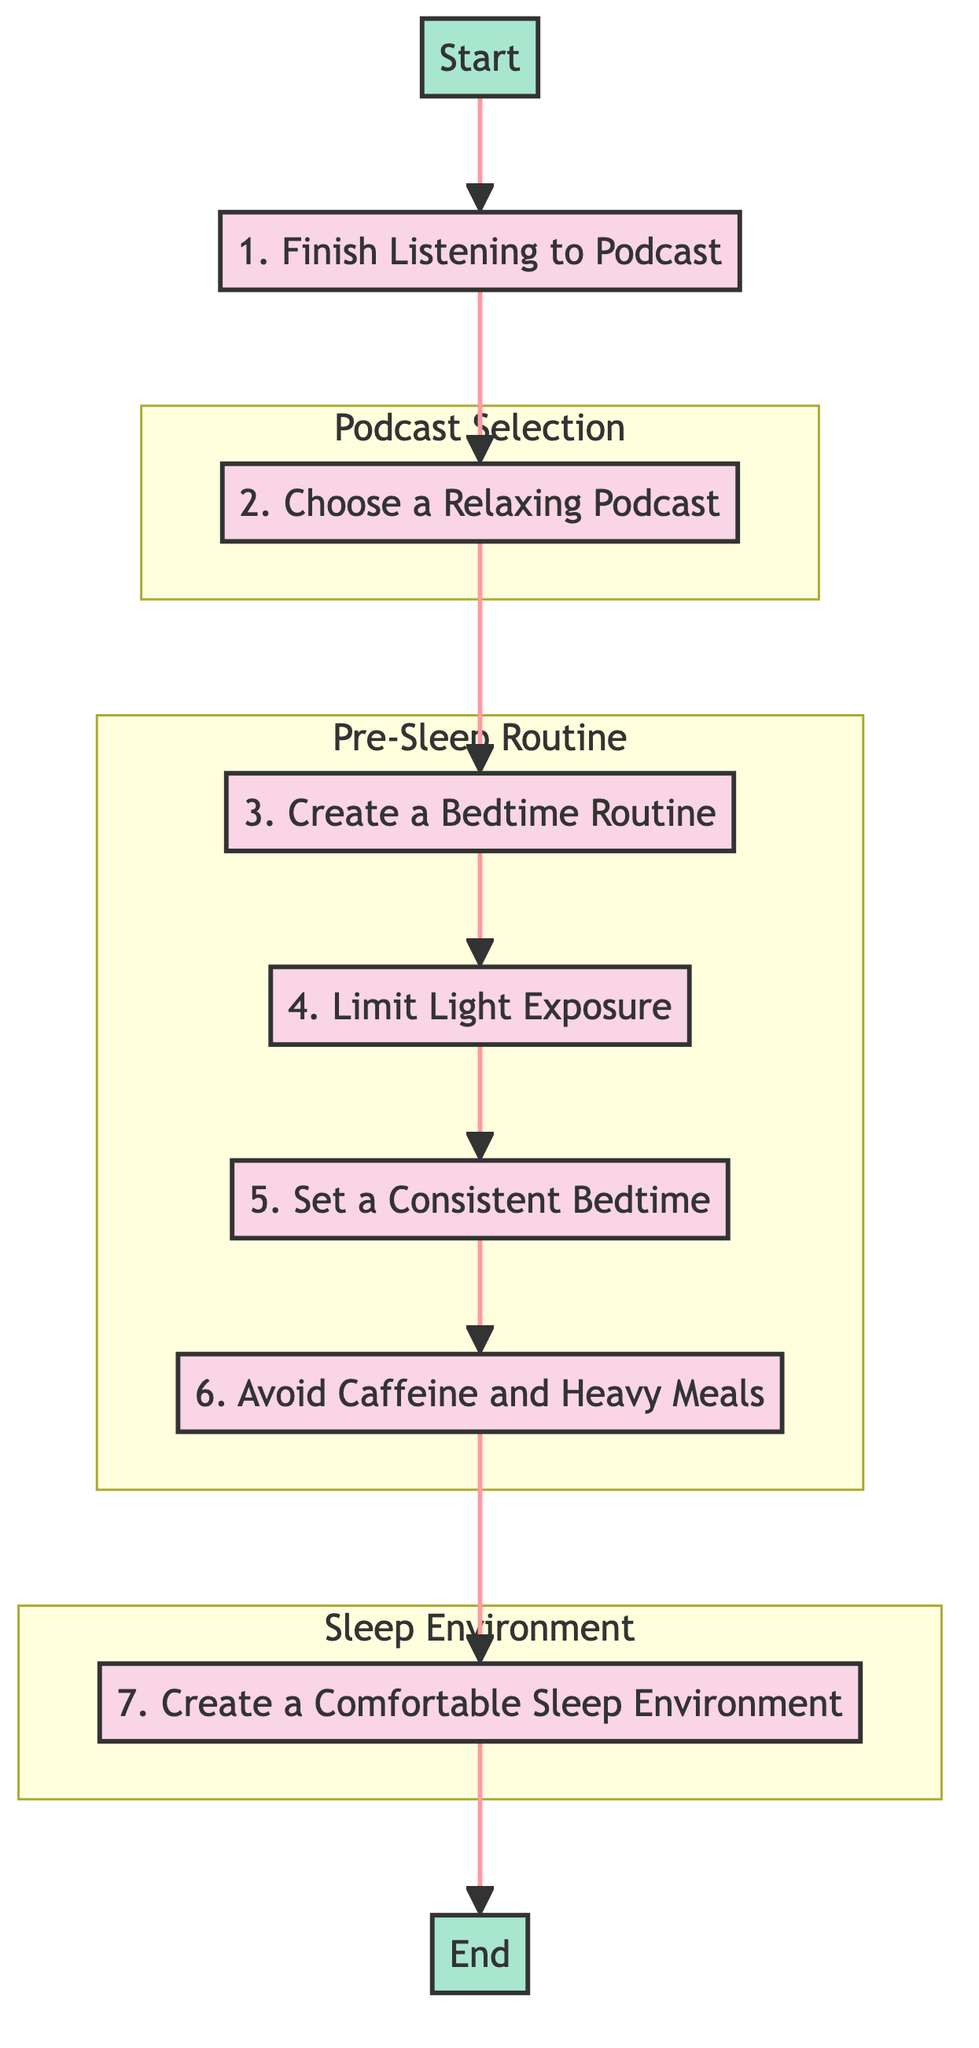What is the first step in the diagram? The first step is "Finish Listening to Podcast," which is represented only by node B in the diagram.
Answer: Finish Listening to Podcast How many steps are shown in the flow chart? Each step is represented by one node, and there are a total of 7 steps from B to H.
Answer: 7 Which step involves dimming lights? In step E, "Limit Light Exposure," it suggests dimming the lights as part of the bedtime routine.
Answer: Limit Light Exposure What is the last step to optimize sleep? The last step is to "Create a Comfortable Sleep Environment," represented by node H in the diagram.
Answer: Create a Comfortable Sleep Environment Which steps are grouped under the Pre-Sleep Routine? Steps D (Create a Bedtime Routine), E (Limit Light Exposure), F (Set a Consistent Bedtime), and G (Avoid Caffeine and Heavy Meals) are all part of that grouping.
Answer: Create a Bedtime Routine, Limit Light Exposure, Set a Consistent Bedtime, Avoid Caffeine and Heavy Meals How does "Choose a Relaxing Podcast" connect to "Finish Listening to Podcast"? "Choose a Relaxing Podcast" is directly following "Finish Listening to Podcast," showing a sequential relationship from B to C.
Answer: Sequential relationship What is the purpose of creating a bedtime routine? The purpose is to engage in a consistent pre-sleep routine to signal to the body that it’s time to wind down and prepare for sleep.
Answer: Signal to wind down What can you do to reduce blue light exposure? You can use an app like "f.lux" to reduce blue light on your devices during the bedtime routine.
Answer: Use f.lux Which step comes after creating a bedtime routine? The step that follows "Create a Bedtime Routine" is "Limit Light Exposure," which is step E.
Answer: Limit Light Exposure 